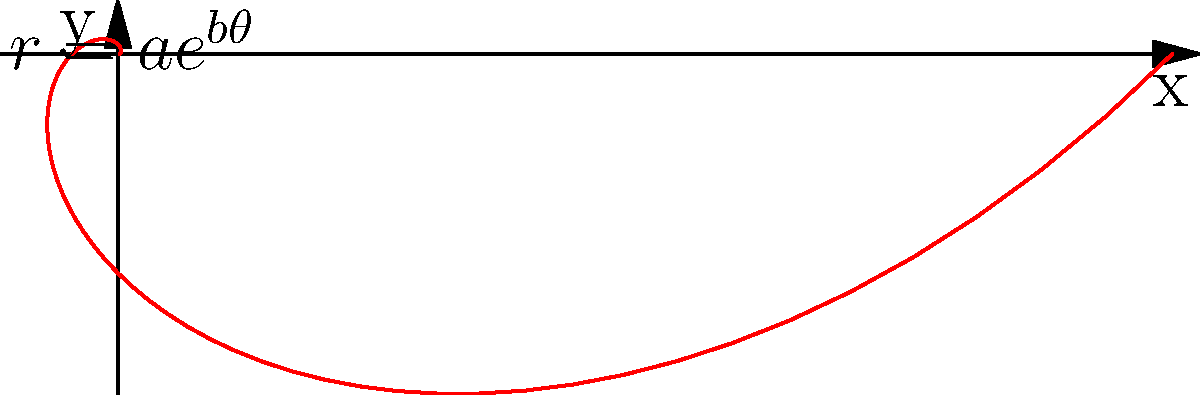As part of your study abroad experience in the US, you encounter a problem involving the arc length of a spiral curve. Consider the logarithmic spiral given by the polar equation $r = 0.2e^{\theta}$ for $0 \leq \theta \leq 2\pi$. Calculate the arc length of this spiral curve. Let's approach this step-by-step:

1) The formula for the arc length of a curve in polar coordinates is:

   $$L = \int_a^b \sqrt{r^2 + \left(\frac{dr}{d\theta}\right)^2} d\theta$$

2) For our spiral, $r = 0.2e^{\theta}$. We need to find $\frac{dr}{d\theta}$:

   $$\frac{dr}{d\theta} = 0.2e^{\theta}$$

3) Now, let's substitute these into our arc length formula:

   $$L = \int_0^{2\pi} \sqrt{(0.2e^{\theta})^2 + (0.2e^{\theta})^2} d\theta$$

4) Simplify inside the square root:

   $$L = \int_0^{2\pi} \sqrt{2(0.2e^{\theta})^2} d\theta = \int_0^{2\pi} 0.2\sqrt{2}e^{\theta} d\theta$$

5) Now we can integrate:

   $$L = 0.2\sqrt{2} [e^{\theta}]_0^{2\pi}$$

6) Evaluate the bounds:

   $$L = 0.2\sqrt{2} (e^{2\pi} - e^0) = 0.2\sqrt{2} (e^{2\pi} - 1)$$

7) Calculate the final value (rounded to 3 decimal places):

   $$L \approx 534.566$$
Answer: $534.566$ 